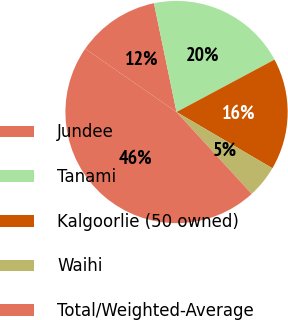<chart> <loc_0><loc_0><loc_500><loc_500><pie_chart><fcel>Jundee<fcel>Tanami<fcel>Kalgoorlie (50 owned)<fcel>Waihi<fcel>Total/Weighted-Average<nl><fcel>12.09%<fcel>20.44%<fcel>16.26%<fcel>4.74%<fcel>46.47%<nl></chart> 